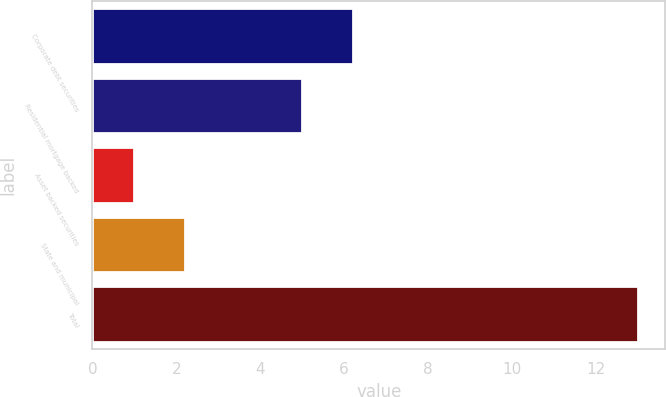<chart> <loc_0><loc_0><loc_500><loc_500><bar_chart><fcel>Corporate debt securities<fcel>Residential mortgage backed<fcel>Asset backed securities<fcel>State and municipal<fcel>Total<nl><fcel>6.2<fcel>5<fcel>1<fcel>2.2<fcel>13<nl></chart> 